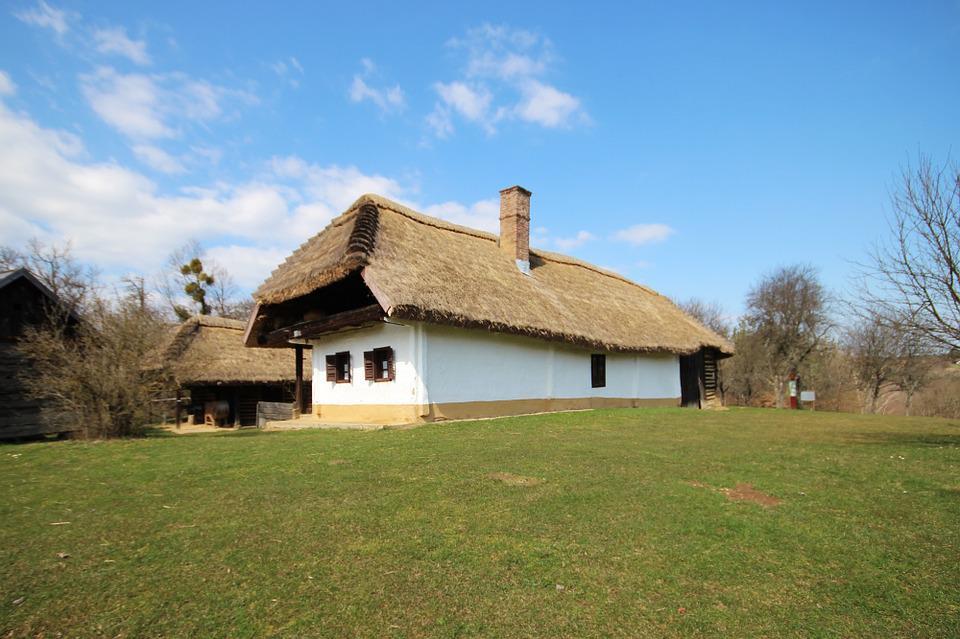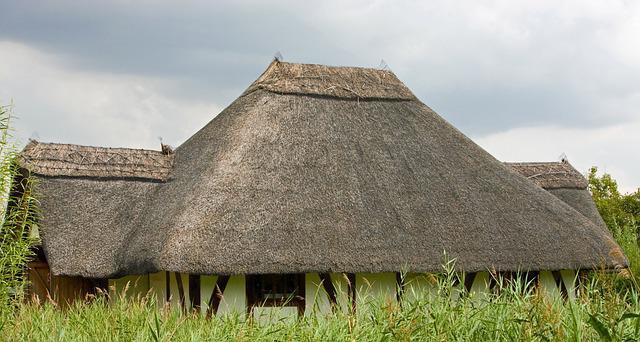The first image is the image on the left, the second image is the image on the right. Analyze the images presented: Is the assertion "Two buildings have second story windows." valid? Answer yes or no. No. The first image is the image on the left, the second image is the image on the right. Assess this claim about the two images: "The building in the image on the right is fenced in.". Correct or not? Answer yes or no. No. 